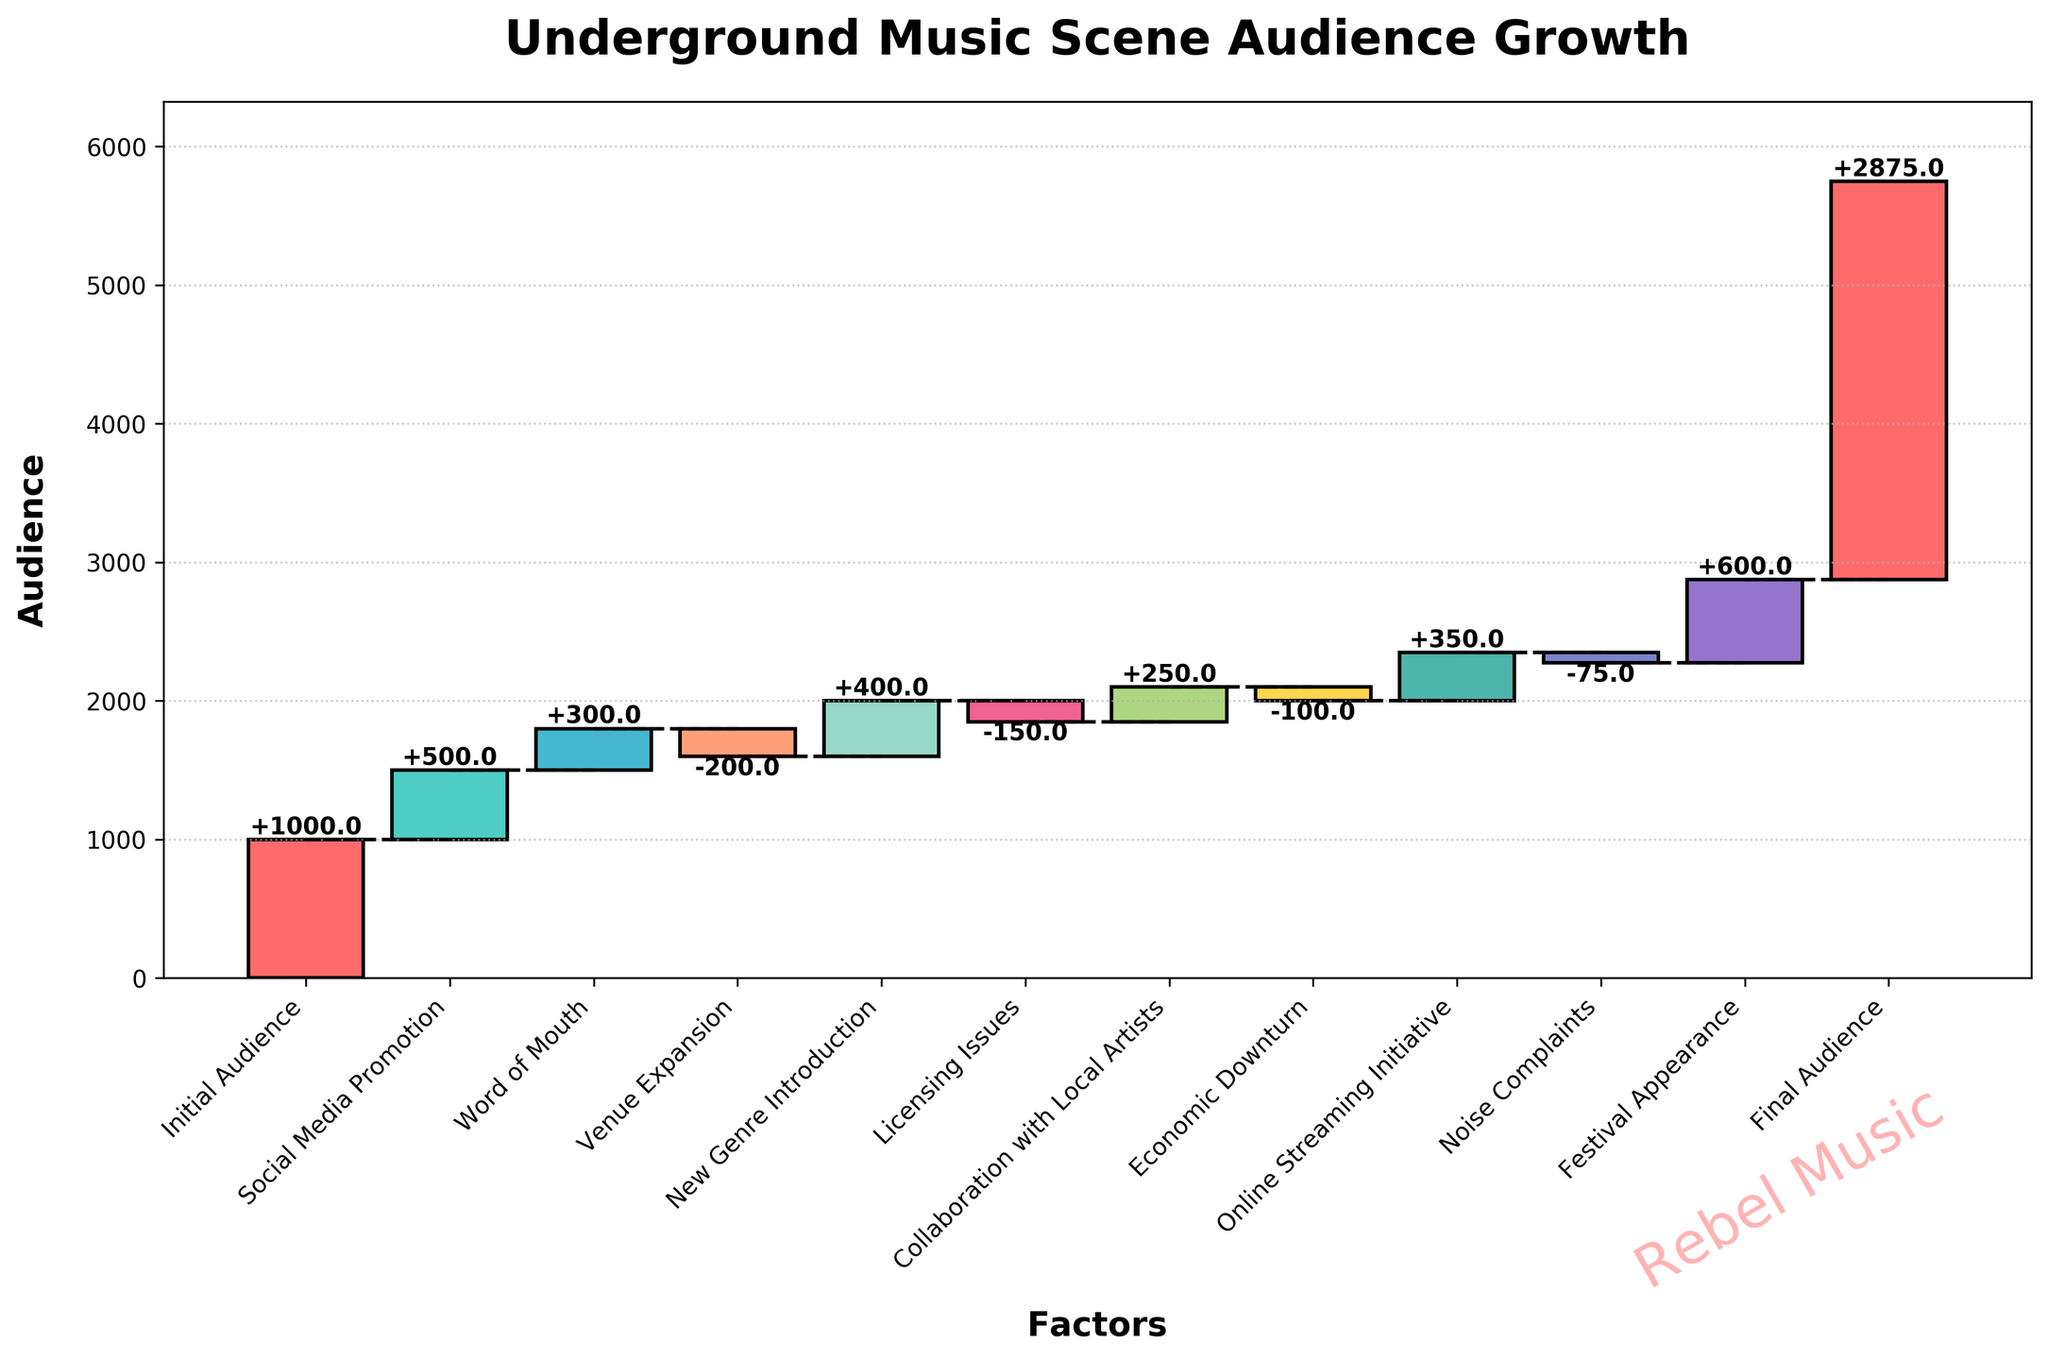What's the title of the chart? The title is usually displayed at the top of the chart. In this case, observe the top portion of the figure to find the title.
Answer: Underground Music Scene Audience Growth How many categories contributed to the audience growth? Count the total labels on the x-axis of the figure. The categories listed are Initial Audience, Social Media Promotion, Word of Mouth, Venue Expansion, New Genre Introduction, Licensing Issues, Collaboration with Local Artists, Economic Downturn, Online Streaming Initiative, Noise Complaints, Festival Appearance, and Final Audience.
Answer: 11 Which category had the largest positive impact on audience growth? Identify the bar with the highest increase in audience compared to the baseline. The category with the largest increase is the one that contributed the most positively.
Answer: Festival Appearance What was the audience count after Social Media Promotion? Start with the Initial Audience (1000) and add the contribution from Social Media Promotion (+500).
Answer: 1500 What is the net change in audience after the New Genre Introduction and Licensing Issues? Calculate the sum of the audience change for New Genre Introduction (+400) and Licensing Issues (-150).
Answer: 250 Which categories decreased the audience size? Look at the bars that go downward from the previous cumulative value. These represent the categories that caused a decline. These categories are Venue Expansion, Licensing Issues, Economic Downturn, and Noise Complaints.
Answer: Venue Expansion, Licensing Issues, Economic Downturn, Noise Complaints How much did the audience grow due to the Collaboration with Local Artists and Online Streaming Initiative combined? Sum the contributions of Collaboration with Local Artists (+250) and Online Streaming Initiative (+350).
Answer: 600 What was the final audience count? The final audience count is noted at the end of the waterfall chart and shows the total accumulated audience.
Answer: 2875 How did the economic downturn affect the audience size? Refer to the specific category 'Economic Downturn' and observe its impact, which is a decrease in the audience.
Answer: -100 What is the difference in audience impact between the Noise Complaints and Festival Appearance? Subtract the impact of Noise Complaints (-75) from the impact of Festival Appearance (+600).
Answer: 675 